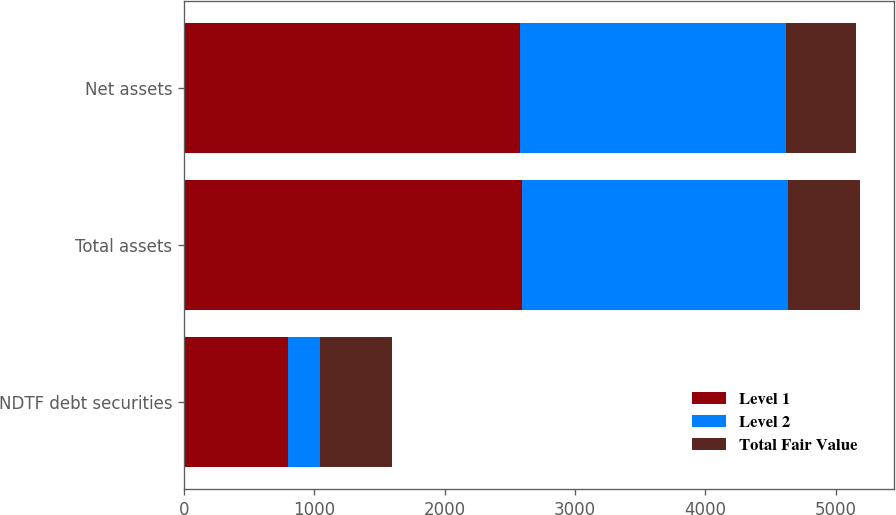Convert chart to OTSL. <chart><loc_0><loc_0><loc_500><loc_500><stacked_bar_chart><ecel><fcel>NDTF debt securities<fcel>Total assets<fcel>Net assets<nl><fcel>Level 1<fcel>796<fcel>2594<fcel>2576<nl><fcel>Level 2<fcel>243<fcel>2040<fcel>2039<nl><fcel>Total Fair Value<fcel>553<fcel>554<fcel>537<nl></chart> 